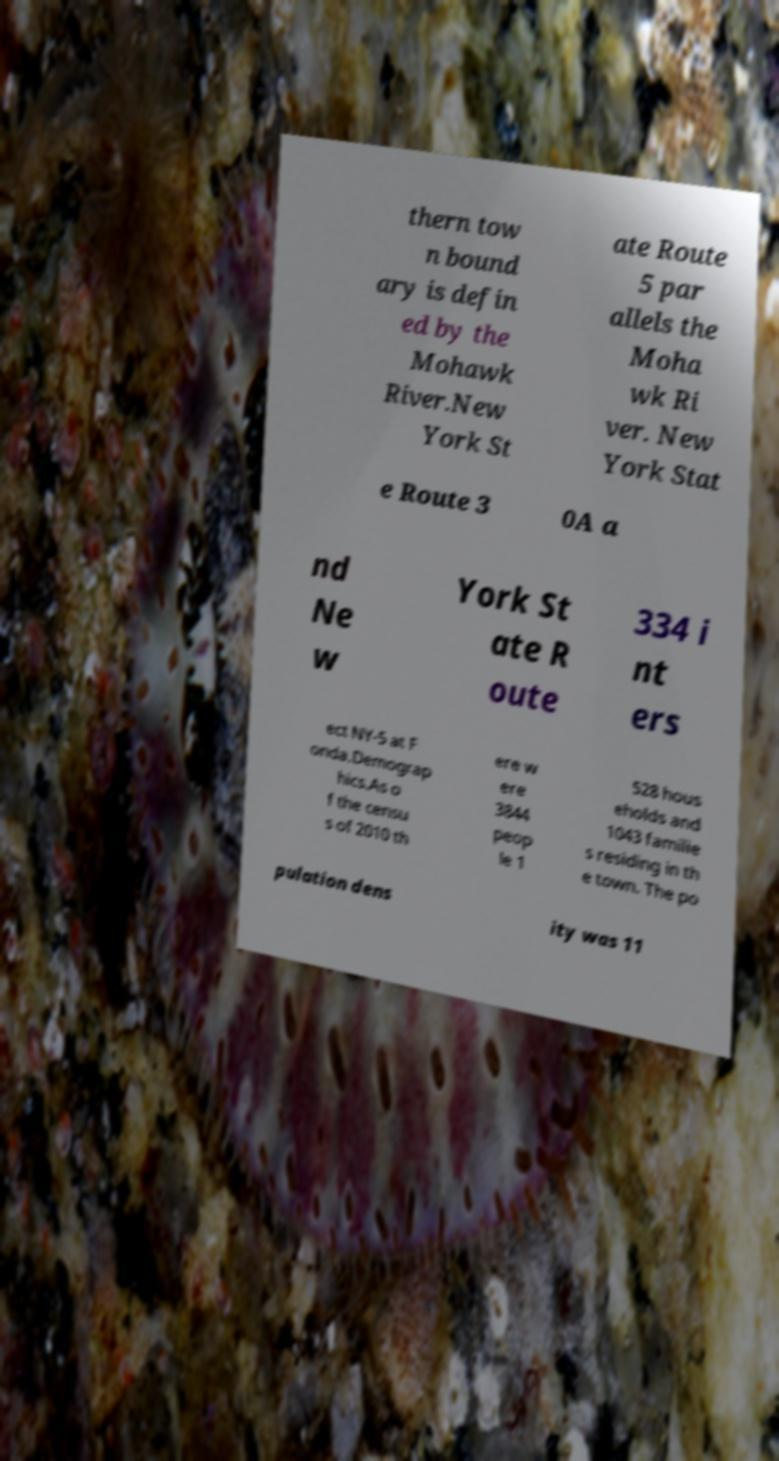Please read and relay the text visible in this image. What does it say? thern tow n bound ary is defin ed by the Mohawk River.New York St ate Route 5 par allels the Moha wk Ri ver. New York Stat e Route 3 0A a nd Ne w York St ate R oute 334 i nt ers ect NY-5 at F onda.Demograp hics.As o f the censu s of 2010 th ere w ere 3844 peop le 1 528 hous eholds and 1043 familie s residing in th e town. The po pulation dens ity was 11 